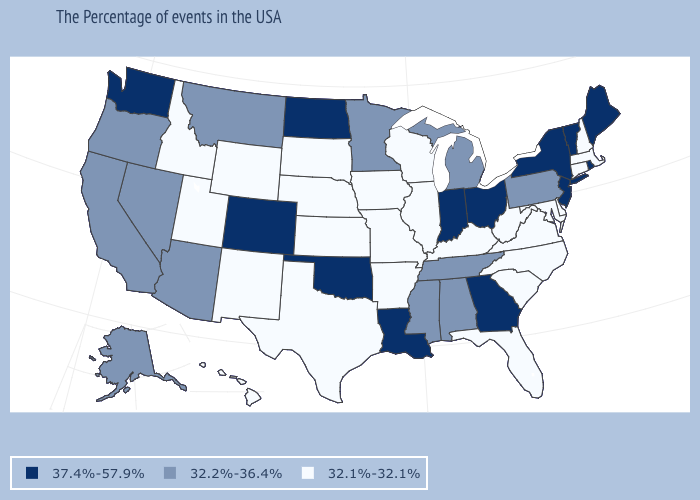Which states hav the highest value in the South?
Write a very short answer. Georgia, Louisiana, Oklahoma. What is the value of California?
Quick response, please. 32.2%-36.4%. What is the value of Nebraska?
Keep it brief. 32.1%-32.1%. What is the value of New Mexico?
Be succinct. 32.1%-32.1%. Name the states that have a value in the range 37.4%-57.9%?
Concise answer only. Maine, Rhode Island, Vermont, New York, New Jersey, Ohio, Georgia, Indiana, Louisiana, Oklahoma, North Dakota, Colorado, Washington. Does Delaware have the lowest value in the South?
Keep it brief. Yes. Among the states that border Arkansas , which have the highest value?
Write a very short answer. Louisiana, Oklahoma. Which states hav the highest value in the South?
Answer briefly. Georgia, Louisiana, Oklahoma. Among the states that border North Carolina , does Virginia have the highest value?
Give a very brief answer. No. Does Rhode Island have a higher value than New Jersey?
Be succinct. No. Does the map have missing data?
Be succinct. No. Among the states that border Idaho , which have the highest value?
Give a very brief answer. Washington. What is the value of Illinois?
Write a very short answer. 32.1%-32.1%. Name the states that have a value in the range 37.4%-57.9%?
Quick response, please. Maine, Rhode Island, Vermont, New York, New Jersey, Ohio, Georgia, Indiana, Louisiana, Oklahoma, North Dakota, Colorado, Washington. Which states have the lowest value in the West?
Concise answer only. Wyoming, New Mexico, Utah, Idaho, Hawaii. 